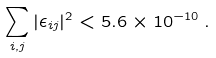<formula> <loc_0><loc_0><loc_500><loc_500>\sum _ { i , j } | \epsilon _ { i j } | ^ { 2 } < 5 . 6 \times 1 0 ^ { - 1 0 } \, .</formula> 